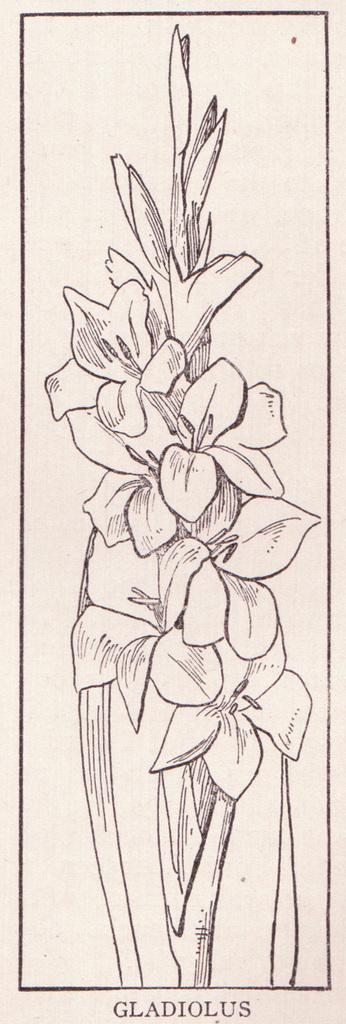What is the main subject of the image? The image contains an art piece. What is the theme of the art piece? The art piece depicts flowers. How many flowers are in the art piece? There are multiple flowers in the art piece. What else can be seen in the art piece besides the flowers? There are stems visible in the art piece. What type of fog can be seen surrounding the flowers in the image? There is no fog present in the image; it features an art piece depicting flowers with visible stems. 